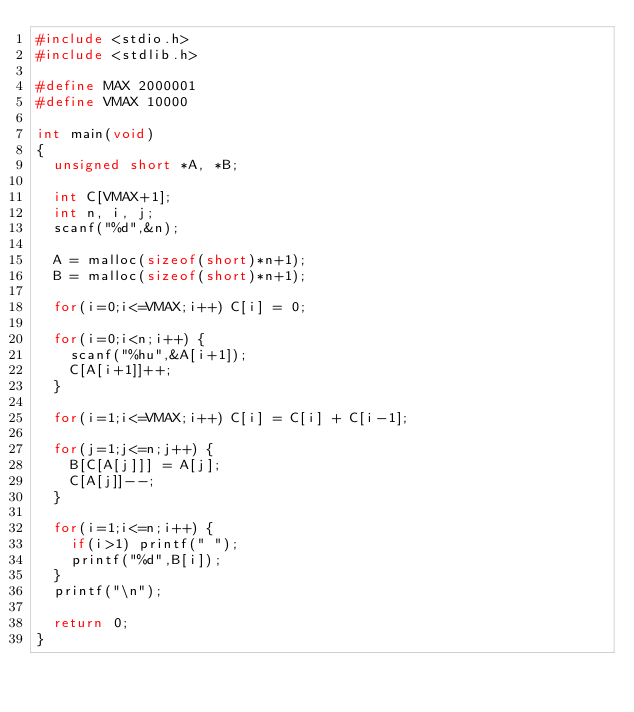Convert code to text. <code><loc_0><loc_0><loc_500><loc_500><_C_>#include <stdio.h>
#include <stdlib.h>

#define MAX 2000001
#define VMAX 10000

int main(void)
{
  unsigned short *A, *B;
  
  int C[VMAX+1];
  int n, i, j;
  scanf("%d",&n);
  
  A = malloc(sizeof(short)*n+1);
  B = malloc(sizeof(short)*n+1);
  
  for(i=0;i<=VMAX;i++) C[i] = 0;
  
  for(i=0;i<n;i++) {
    scanf("%hu",&A[i+1]);
    C[A[i+1]]++;
  }
  
  for(i=1;i<=VMAX;i++) C[i] = C[i] + C[i-1];
  
  for(j=1;j<=n;j++) {
    B[C[A[j]]] = A[j];
    C[A[j]]--;
  }
  
  for(i=1;i<=n;i++) {
    if(i>1) printf(" ");
    printf("%d",B[i]);
  }
  printf("\n");
  
  return 0;
}
</code> 